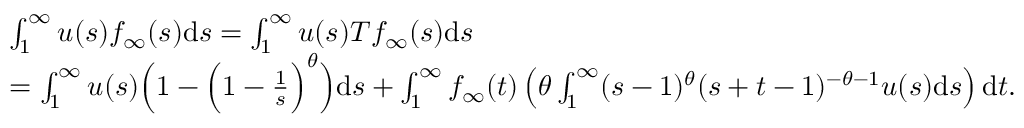<formula> <loc_0><loc_0><loc_500><loc_500>\begin{array} { r l } & { \int _ { 1 } ^ { \infty } u ( s ) f _ { \infty } ( s ) d s = \int _ { 1 } ^ { \infty } u ( s ) T f _ { \infty } ( s ) d s } \\ & { = \int _ { 1 } ^ { \infty } u ( s ) \left ( 1 - \left ( 1 - \frac { 1 } s } \right ) ^ { \theta } \right ) d s + \int _ { 1 } ^ { \infty } f _ { \infty } ( t ) \left ( \theta \int _ { 1 } ^ { \infty } ( s - 1 ) ^ { \theta } ( s + t - 1 ) ^ { - \theta - 1 } u ( s ) d s \right ) d t . } \end{array}</formula> 